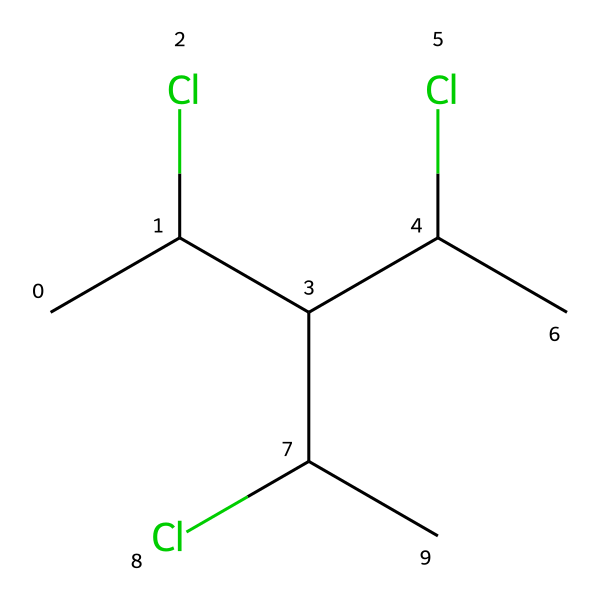What is the total number of chlorine atoms in this chemical? The SMILES representation CC(Cl)C(C(Cl)C)C(Cl)C shows three chlorine atoms (Cl) attached to the carbon backbone.
Answer: three What is the total number of carbon atoms in this chemical? Analyzing the SMILES structure, CC(Cl)C(C(Cl)C)C(Cl)C indicates there are four carbon atoms (C) in the main structure.
Answer: four Is this chemical classified as a thermoplastic or thermoset? Polyvinyl chloride (PVC), as shown in the provided SMILES, is a thermoplastic due to its ability to be re-melted and re-formed.
Answer: thermoplastic What type of bonds are primarily present in this chemical? The chemical structure contains primarily single (sigma) bonds between carbon and chlorine atoms as well as between carbon and carbon atoms.
Answer: single bonds How does the presence of chlorine atoms affect the properties of this polymer? The chlorine atoms in the polymer structure contribute to properties such as increased stability and resistance to fire and chemicals, influencing the material's behavior in applications.
Answer: increased stability What functional groups are evident in this chemical structure? Looking at the structure, the chlorine substituents indicate the presence of haloalkane functional groups amidst the carbon framework.
Answer: haloalkane What is a typical application of this chemical in medical devices? PVC is commonly used in medical tubing and storage containers due to its durability, flexibility, and resistance to various chemicals.
Answer: medical tubing and storage containers 